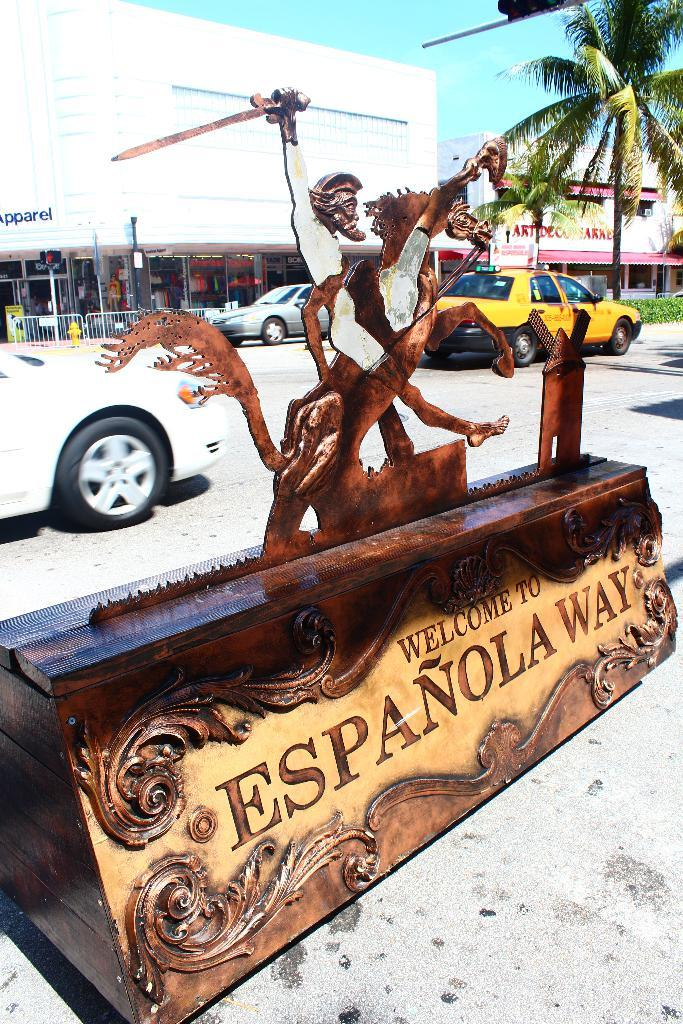Provide a one-sentence caption for the provided image. A wooden sculpture says "welcome to Espanola Way". 